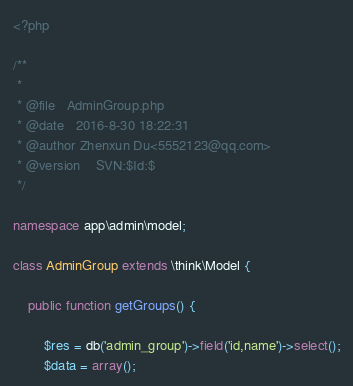Convert code to text. <code><loc_0><loc_0><loc_500><loc_500><_PHP_><?php

/**
 *  
 * @file   AdminGroup.php  
 * @date   2016-8-30 18:22:31 
 * @author Zhenxun Du<5552123@qq.com>  
 * @version    SVN:$Id:$ 
 */

namespace app\admin\model;

class AdminGroup extends \think\Model {

    public function getGroups() {

        $res = db('admin_group')->field('id,name')->select();
        $data = array();</code> 